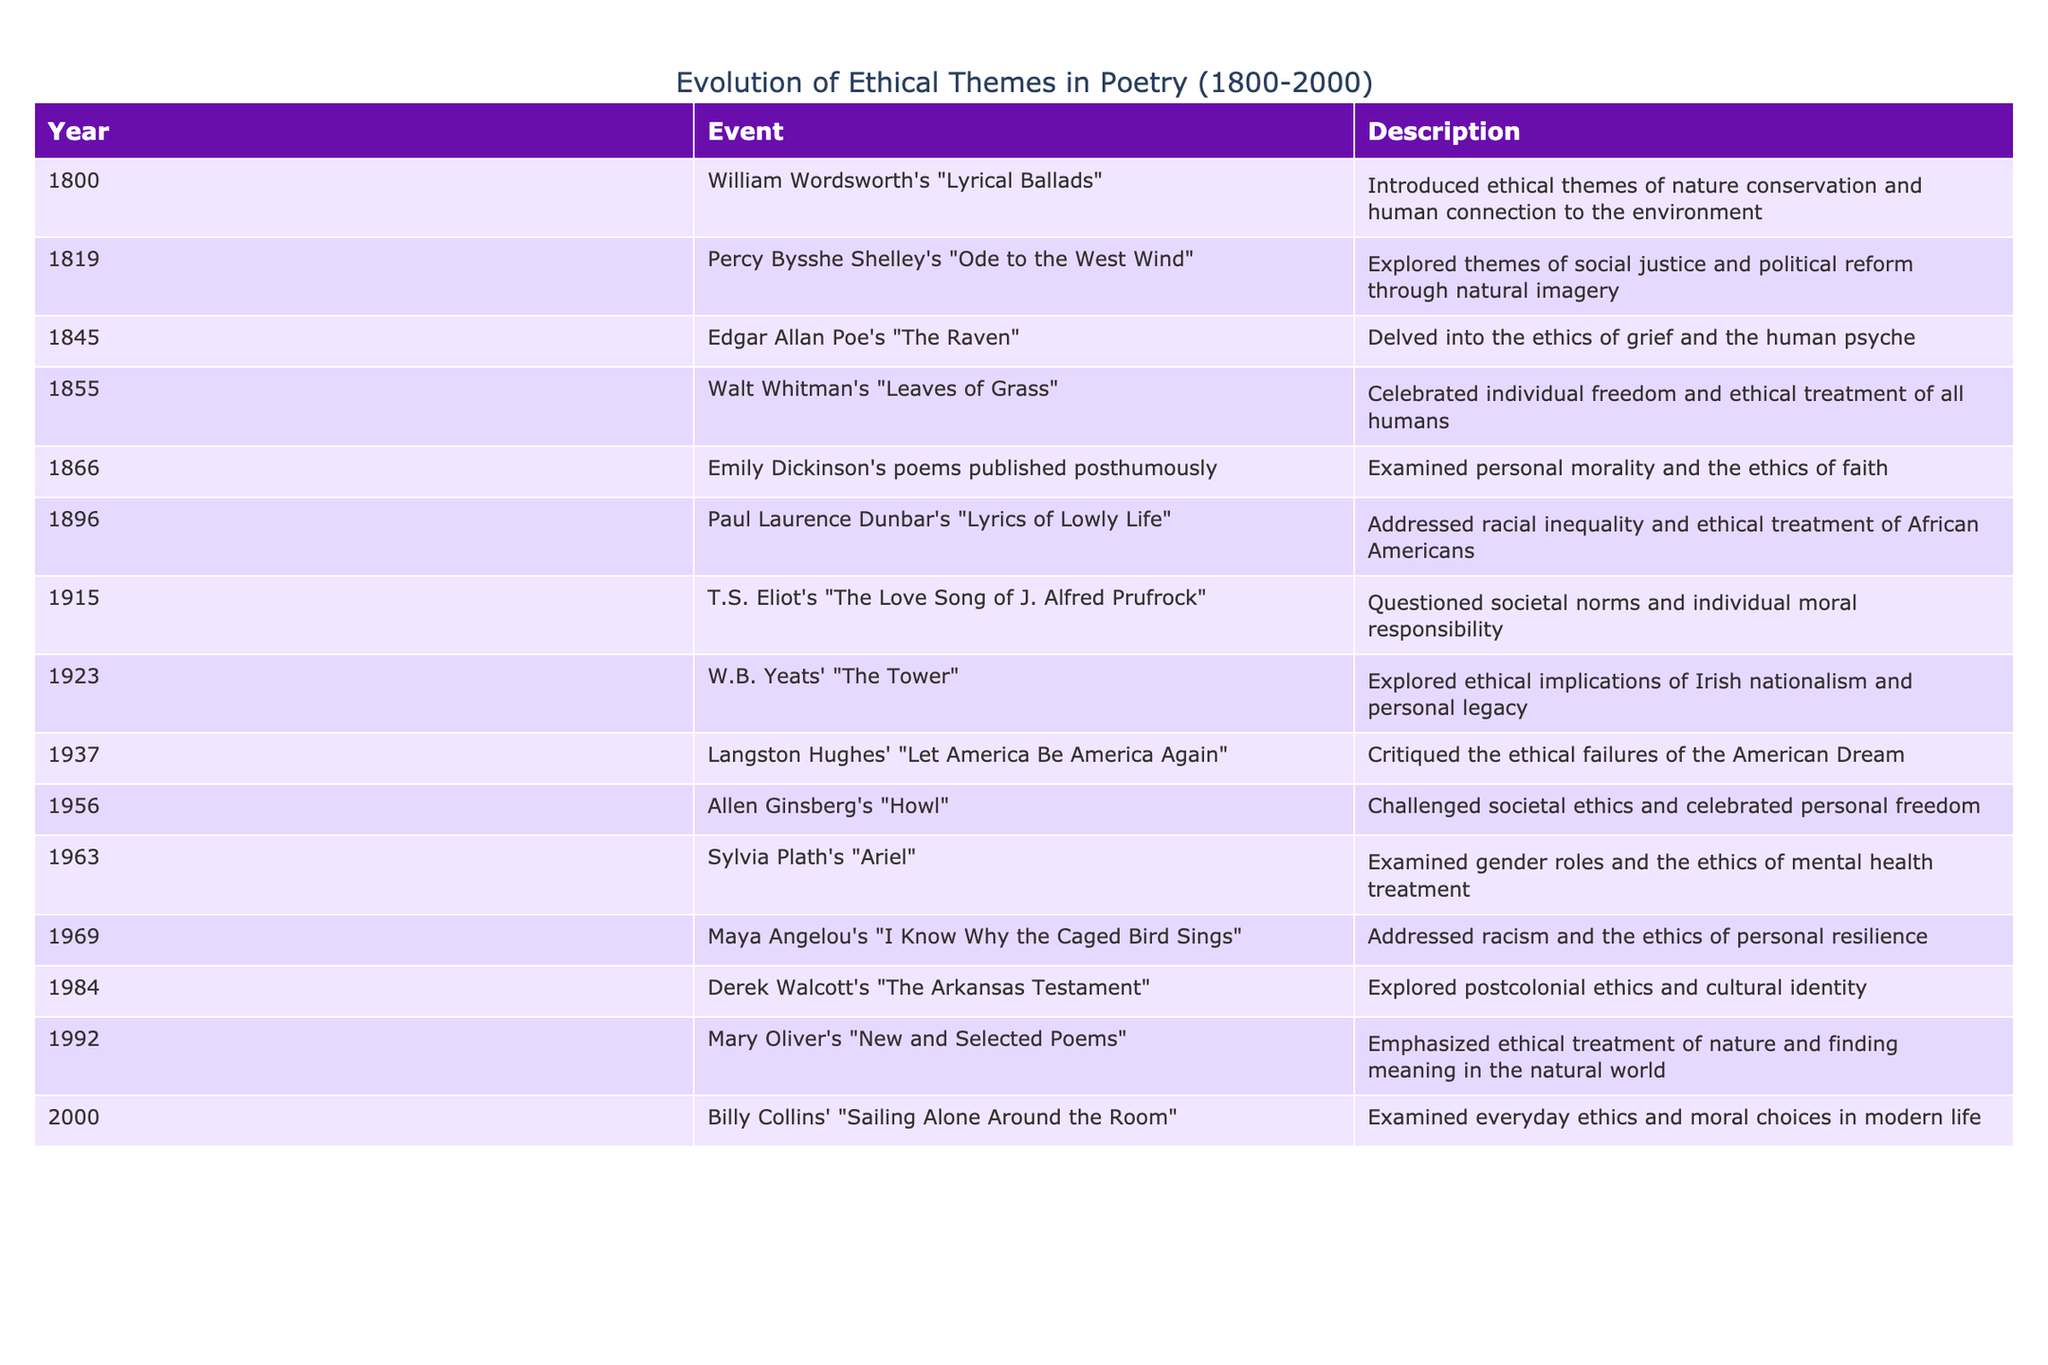What year was Edgar Allan Poe's "The Raven" published? The table shows that "The Raven" by Edgar Allan Poe was released in the year 1845. Thus, this information can be directly retrieved from the table.
Answer: 1845 Which poet's work in 1855 emphasized individual freedom? According to the table, Walt Whitman's "Leaves of Grass," published in 1855, celebrated individual freedom and ethical treatment of all humans. This can be found by looking specifically at the 1855 row of the table.
Answer: Walt Whitman Did T.S. Eliot address social norms in his poem? The table states that T.S. Eliot's "The Love Song of J. Alfred Prufrock," published in 1915, questioned societal norms and individual moral responsibility. Therefore, the fact that he addressed social norms is true.
Answer: Yes How many events from the 1960s dealt with gender or racial ethics? The table lists "Ariel" by Sylvia Plath from 1963 and "I Know Why the Caged Bird Sings" by Maya Angelou from 1969. Both of these events relate to gender and racial ethics, respectively, indicating there are two such events in the 1960s.
Answer: 2 Which poet is noted for addressing the ethical treatment of nature in the 1990s? The table indicates that Mary Oliver's "New and Selected Poems," published in 1992, emphasized ethical treatment of nature. This specific information can be retrieved by looking at the work listed under the 1992 entry.
Answer: Mary Oliver How many poets highlighted ethical failures in American culture across the 20th century? From the table, two poets highlighted ethical failures - Langston Hughes with "Let America Be America Again" in 1937, and Allen Ginsberg with "Howl" in 1956. Adding these gives a total of two poets addressing this theme in the 20th century.
Answer: 2 Was Emily Dickinson's work published during her lifetime? The table mentions that Emily Dickinson's poems were published posthumously in 1866. Therefore, the answer is that her work was not published during her lifetime.
Answer: No What is the earliest year mentioned in the context of ethical themes in poetry? By reviewing the first entry in the table, it is clear that the earliest year mentioned is 1800, where William Wordsworth introduced ethical themes. This requires simply checking the first row of the data provided.
Answer: 1800 Which work is associated with postcolonial ethics, and when was it published? The table shows that Derek Walcott's "The Arkansas Testament," published in 1984, explored postcolonial ethics. This information can be found directly in the 1984 row of the table.
Answer: Derek Walcott, 1984 